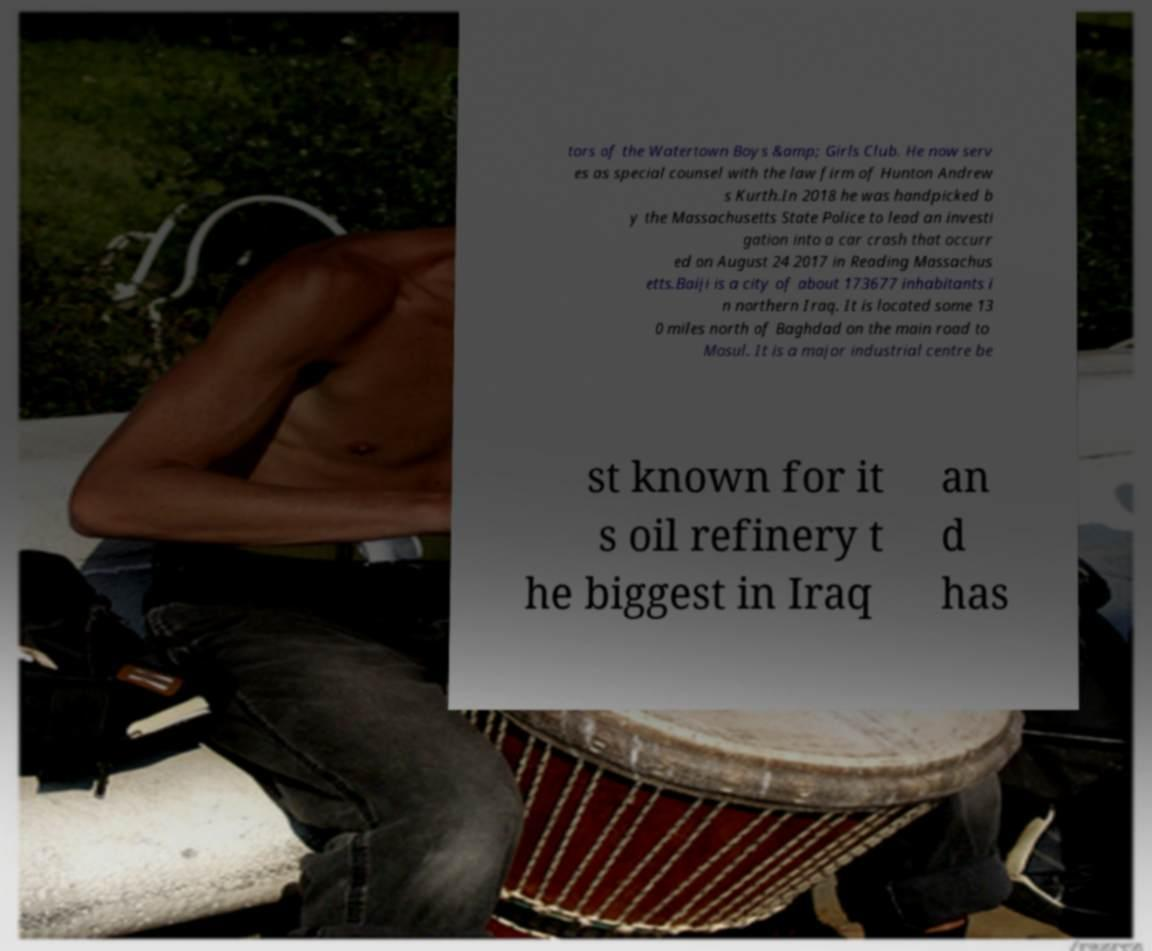Could you extract and type out the text from this image? tors of the Watertown Boys &amp; Girls Club. He now serv es as special counsel with the law firm of Hunton Andrew s Kurth.In 2018 he was handpicked b y the Massachusetts State Police to lead an investi gation into a car crash that occurr ed on August 24 2017 in Reading Massachus etts.Baiji is a city of about 173677 inhabitants i n northern Iraq. It is located some 13 0 miles north of Baghdad on the main road to Mosul. It is a major industrial centre be st known for it s oil refinery t he biggest in Iraq an d has 